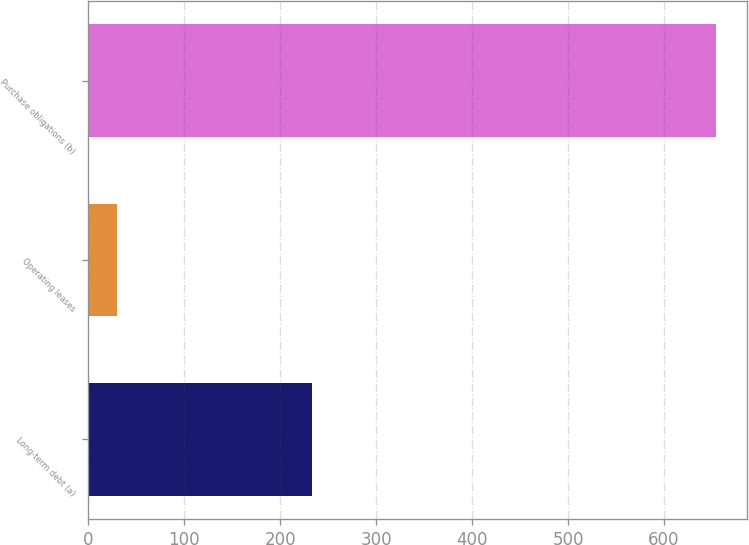<chart> <loc_0><loc_0><loc_500><loc_500><bar_chart><fcel>Long-term debt (a)<fcel>Operating leases<fcel>Purchase obligations (b)<nl><fcel>233<fcel>30<fcel>654<nl></chart> 